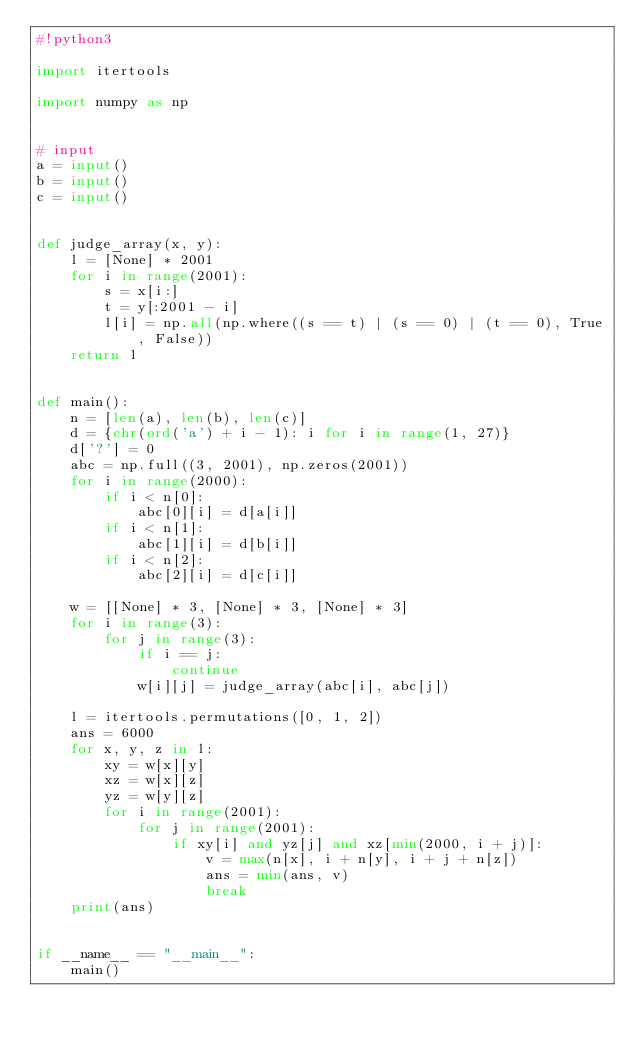Convert code to text. <code><loc_0><loc_0><loc_500><loc_500><_Python_>#!python3

import itertools

import numpy as np


# input
a = input()
b = input()
c = input()


def judge_array(x, y):
    l = [None] * 2001
    for i in range(2001):
        s = x[i:]
        t = y[:2001 - i]
        l[i] = np.all(np.where((s == t) | (s == 0) | (t == 0), True, False))
    return l


def main():
    n = [len(a), len(b), len(c)]
    d = {chr(ord('a') + i - 1): i for i in range(1, 27)}
    d['?'] = 0
    abc = np.full((3, 2001), np.zeros(2001))
    for i in range(2000):
        if i < n[0]:
            abc[0][i] = d[a[i]]
        if i < n[1]:
            abc[1][i] = d[b[i]]
        if i < n[2]:
            abc[2][i] = d[c[i]]

    w = [[None] * 3, [None] * 3, [None] * 3]
    for i in range(3):
        for j in range(3):
            if i == j:
                continue
            w[i][j] = judge_array(abc[i], abc[j])
    
    l = itertools.permutations([0, 1, 2])
    ans = 6000
    for x, y, z in l:
        xy = w[x][y]
        xz = w[x][z]
        yz = w[y][z]
        for i in range(2001):
            for j in range(2001):
                if xy[i] and yz[j] and xz[min(2000, i + j)]:
                    v = max(n[x], i + n[y], i + j + n[z])
                    ans = min(ans, v)
                    break
    print(ans)


if __name__ == "__main__":
    main()
</code> 